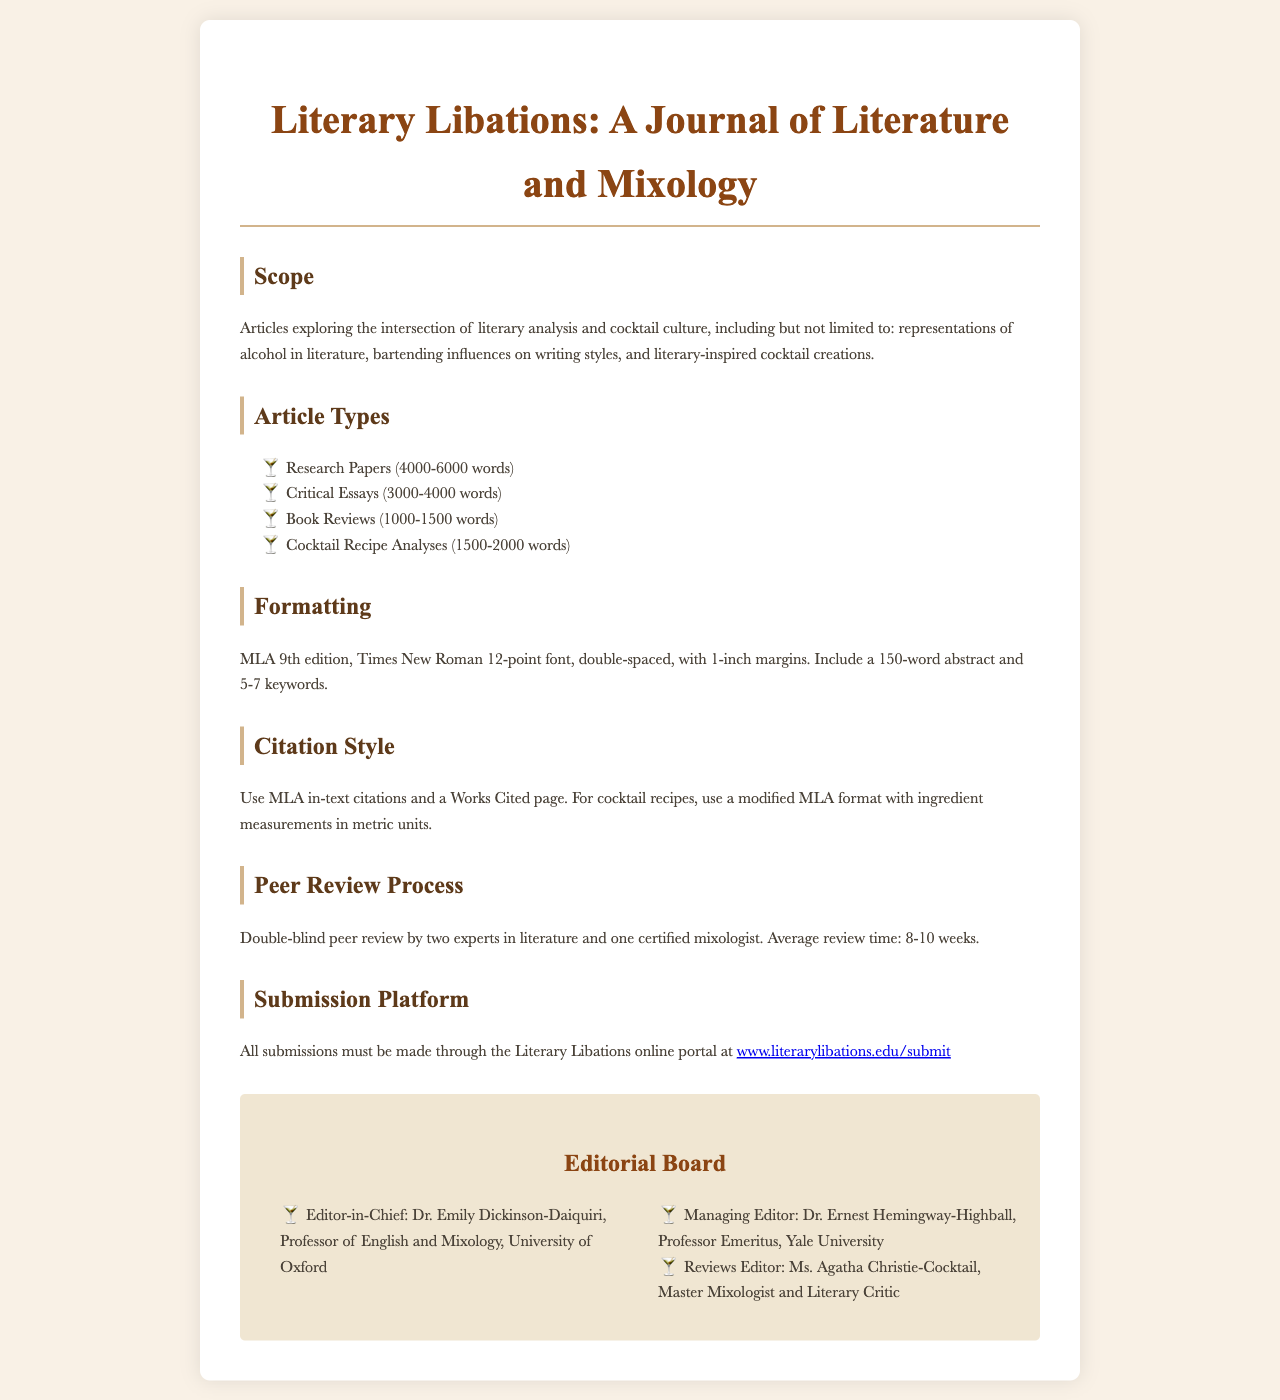What is the title of the journal? The title of the journal is prominently displayed at the top of the document, indicating the focus of the publication.
Answer: Literary Libations: A Journal of Literature and Mixology What is the maximum word count for Research Papers? The document specifies the word count range for different article types, including Research Papers.
Answer: 6000 words Who is the Editor-in-Chief? The document lists names and titles of the editorial board members clearly along with their roles.
Answer: Dr. Emily Dickinson-Daiquiri What citation style is required for the articles? The guidelines specify the citation style to be used in the submissions.
Answer: MLA How many experts are involved in the peer review process? The document mentions the number of reviewers engaged in evaluating submissions.
Answer: Three What is the typical review time for articles? The document provides the average duration for the peer review process.
Answer: 8-10 weeks What is required alongside the article submission in terms of abstract? The document outlines specific requirements for article formatting, including the abstract.
Answer: 150-word abstract Where must submissions be made? The document provides information on the platform for submission, which is essential for prospective authors.
Answer: Literary Libations online portal What type of articles is specifically mentioned regarding cocktail recipe analyses? The document categorizes different types of articles accepted for submission, including one specific to cocktail recipes.
Answer: Cocktail Recipe Analyses 